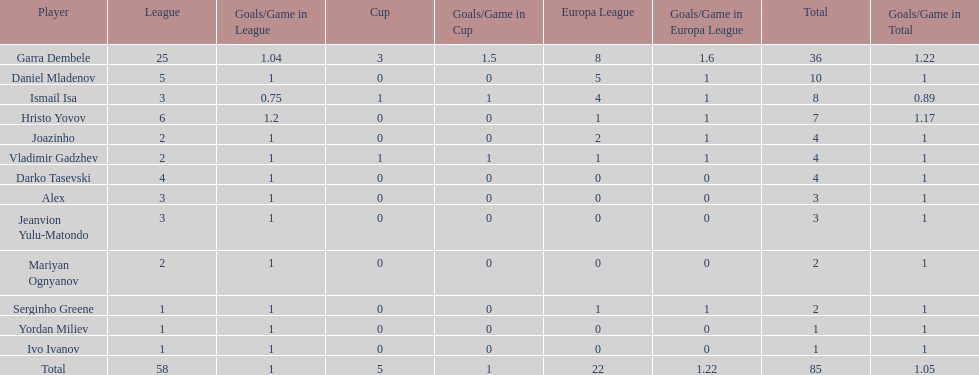How many of the players did not score any goals in the cup? 10. 